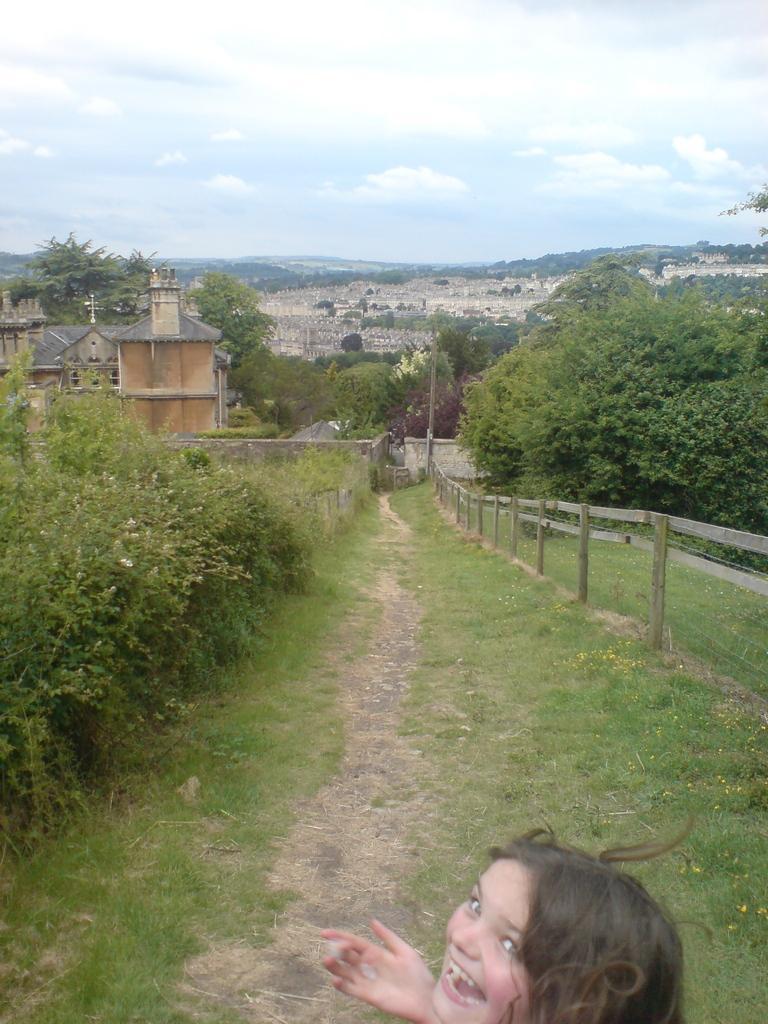Can you describe this image briefly? In this image we can see a girl, grass, plants. In the background of the image there are buildings, trees, sky and clouds. 